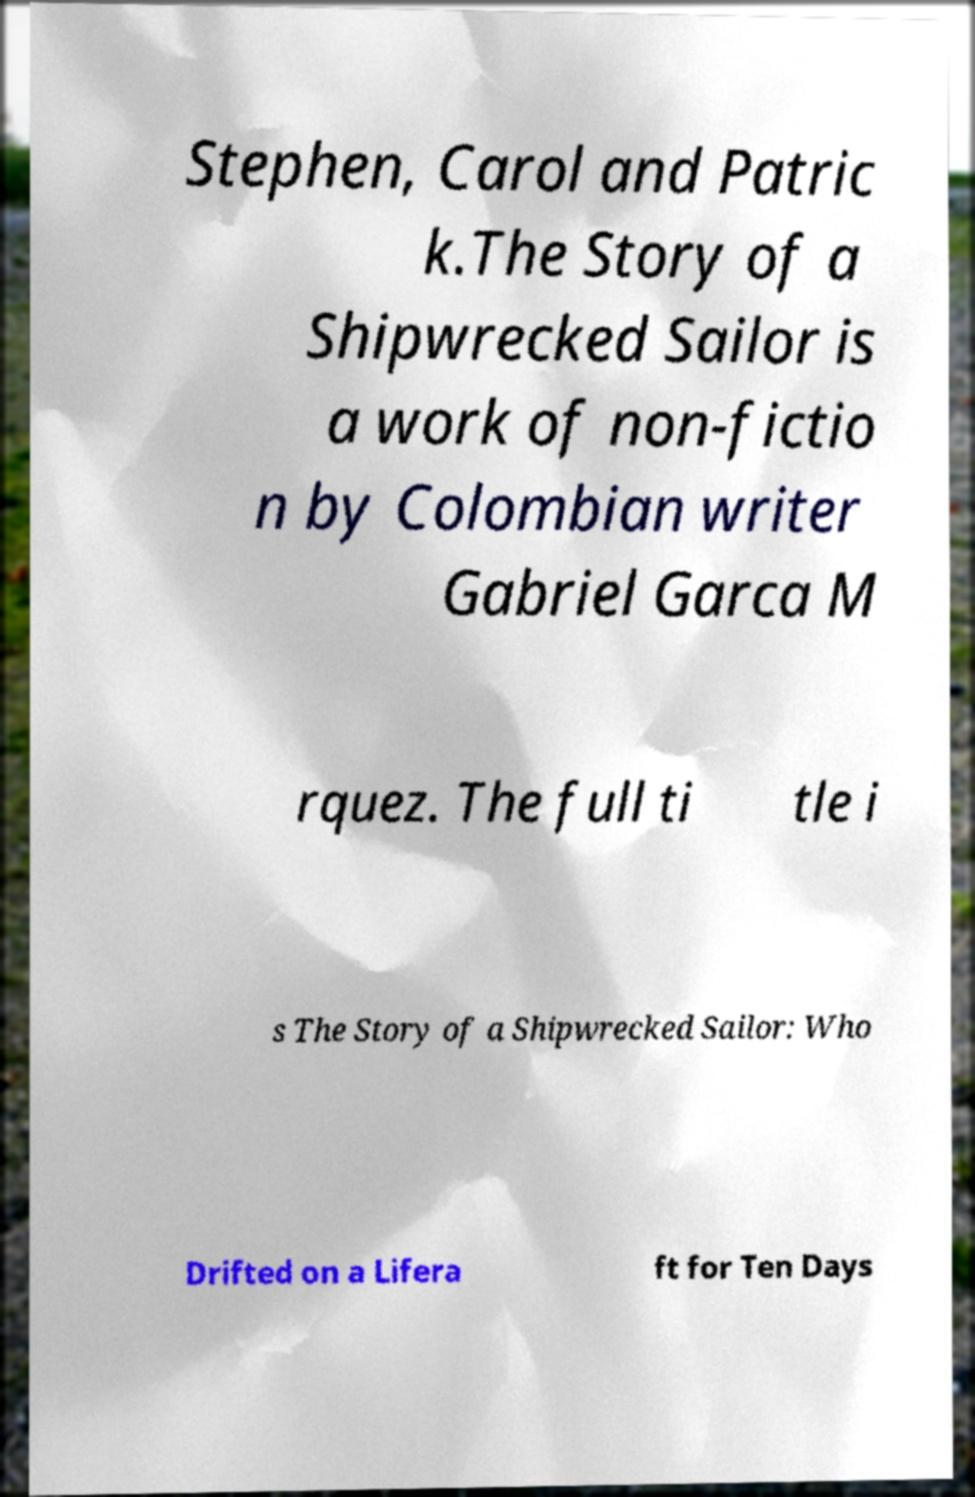For documentation purposes, I need the text within this image transcribed. Could you provide that? Stephen, Carol and Patric k.The Story of a Shipwrecked Sailor is a work of non-fictio n by Colombian writer Gabriel Garca M rquez. The full ti tle i s The Story of a Shipwrecked Sailor: Who Drifted on a Lifera ft for Ten Days 